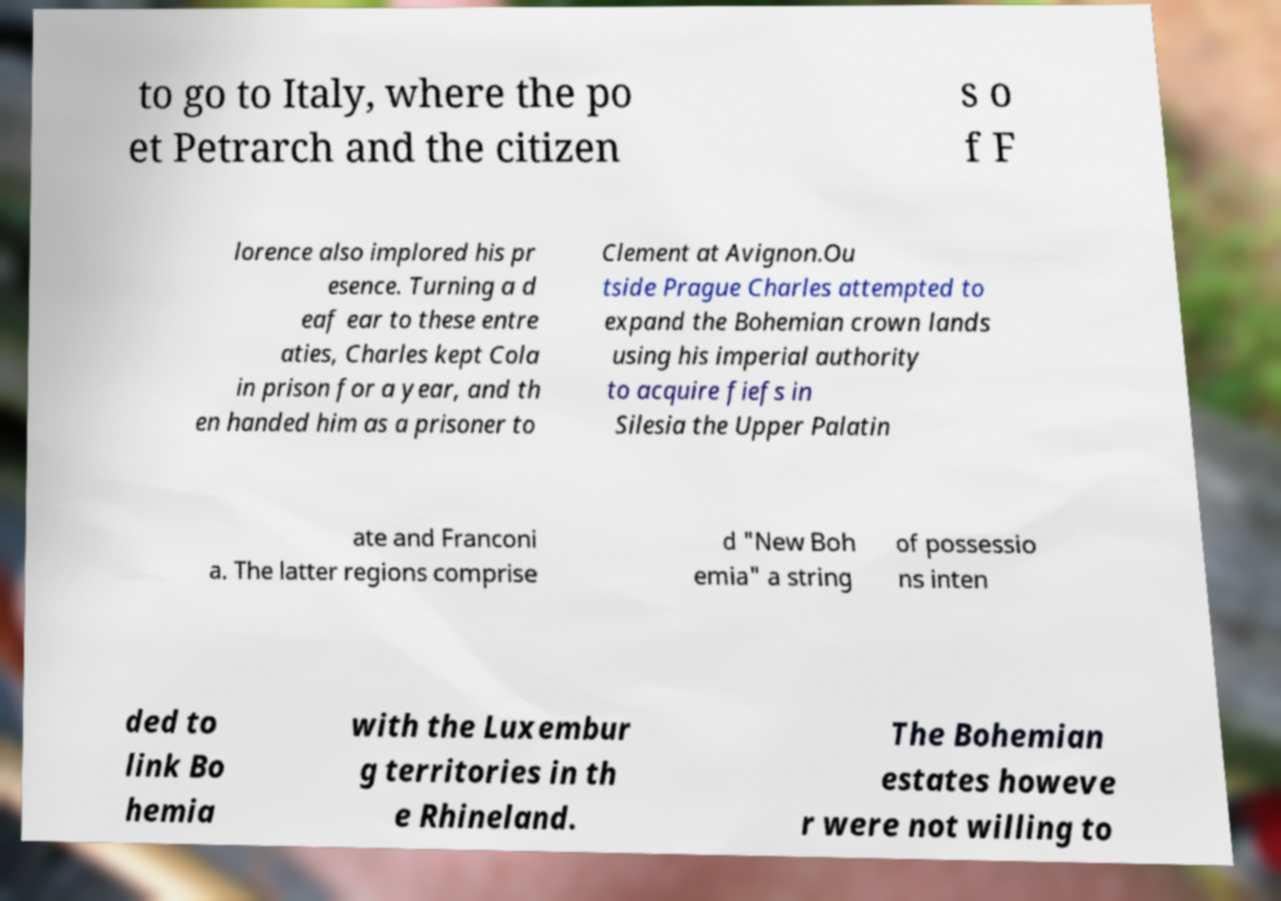There's text embedded in this image that I need extracted. Can you transcribe it verbatim? to go to Italy, where the po et Petrarch and the citizen s o f F lorence also implored his pr esence. Turning a d eaf ear to these entre aties, Charles kept Cola in prison for a year, and th en handed him as a prisoner to Clement at Avignon.Ou tside Prague Charles attempted to expand the Bohemian crown lands using his imperial authority to acquire fiefs in Silesia the Upper Palatin ate and Franconi a. The latter regions comprise d "New Boh emia" a string of possessio ns inten ded to link Bo hemia with the Luxembur g territories in th e Rhineland. The Bohemian estates howeve r were not willing to 